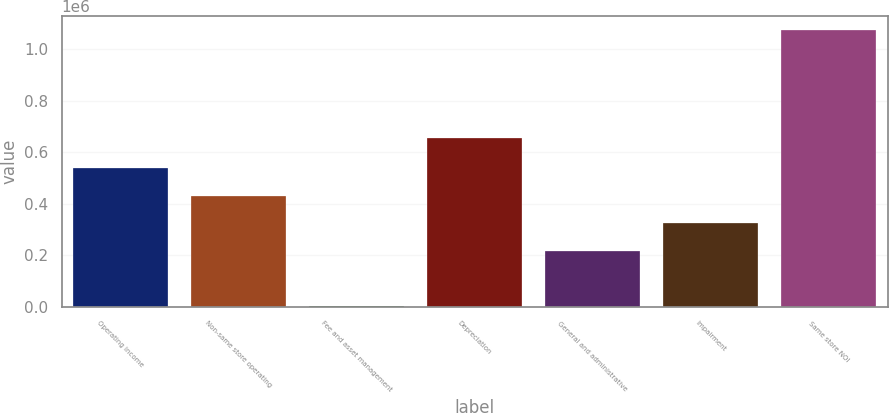Convert chart. <chart><loc_0><loc_0><loc_500><loc_500><bar_chart><fcel>Operating income<fcel>Non-same store operating<fcel>Fee and asset management<fcel>Depreciation<fcel>General and administrative<fcel>Impairment<fcel>Same store NOI<nl><fcel>539372<fcel>432526<fcel>5140<fcel>656633<fcel>218833<fcel>325680<fcel>1.0736e+06<nl></chart> 